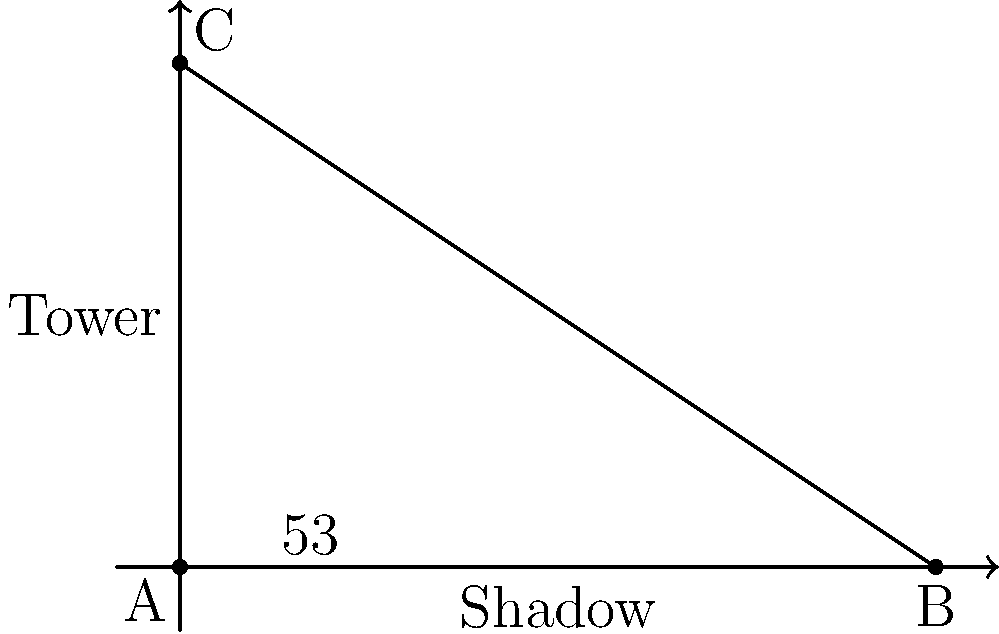As a small business owner inspired by a radio show, you're measuring the height of your new radio tower. On a sunny day, you notice that the angle of elevation from the tip of the tower's shadow to its top is 53°. If the shadow is 6 meters long, what is the height of the tower? Round your answer to the nearest tenth of a meter. Let's approach this step-by-step:

1) First, let's identify what we know:
   - The angle of elevation is 53°
   - The length of the shadow is 6 meters
   - We need to find the height of the tower

2) This scenario forms a right-angled triangle, where:
   - The shadow length is the base of the triangle
   - The tower height is the opposite side to the 53° angle
   - The hypotenuse is the line from the tip of the shadow to the top of the tower

3) We can use the tangent trigonometric function to solve this. Recall that:

   $\tan(\theta) = \frac{\text{opposite}}{\text{adjacent}}$

4) In our case:
   
   $\tan(53°) = \frac{\text{tower height}}{\text{shadow length}}$

5) Let's substitute the known values:

   $\tan(53°) = \frac{\text{tower height}}{6}$

6) To solve for the tower height, we multiply both sides by 6:

   $6 \cdot \tan(53°) = \text{tower height}$

7) Now, let's calculate:
   
   $\text{tower height} = 6 \cdot \tan(53°) \approx 6 \cdot 1.3270 \approx 7.9620$ meters

8) Rounding to the nearest tenth:

   $\text{tower height} \approx 8.0$ meters
Answer: 8.0 meters 